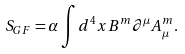<formula> <loc_0><loc_0><loc_500><loc_500>S _ { G F } = \alpha \int d ^ { 4 } x B ^ { m } \partial ^ { \mu } A _ { \mu } ^ { m } .</formula> 